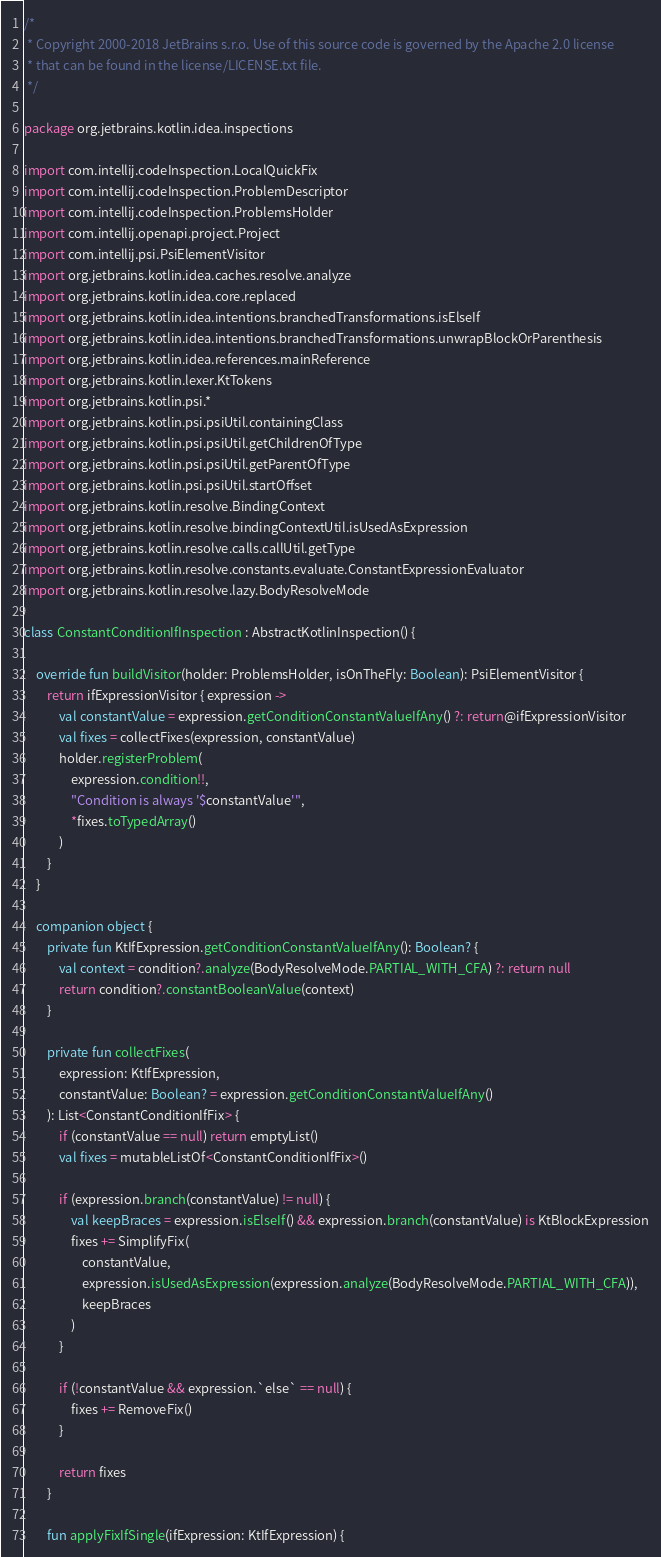<code> <loc_0><loc_0><loc_500><loc_500><_Kotlin_>/*
 * Copyright 2000-2018 JetBrains s.r.o. Use of this source code is governed by the Apache 2.0 license
 * that can be found in the license/LICENSE.txt file.
 */

package org.jetbrains.kotlin.idea.inspections

import com.intellij.codeInspection.LocalQuickFix
import com.intellij.codeInspection.ProblemDescriptor
import com.intellij.codeInspection.ProblemsHolder
import com.intellij.openapi.project.Project
import com.intellij.psi.PsiElementVisitor
import org.jetbrains.kotlin.idea.caches.resolve.analyze
import org.jetbrains.kotlin.idea.core.replaced
import org.jetbrains.kotlin.idea.intentions.branchedTransformations.isElseIf
import org.jetbrains.kotlin.idea.intentions.branchedTransformations.unwrapBlockOrParenthesis
import org.jetbrains.kotlin.idea.references.mainReference
import org.jetbrains.kotlin.lexer.KtTokens
import org.jetbrains.kotlin.psi.*
import org.jetbrains.kotlin.psi.psiUtil.containingClass
import org.jetbrains.kotlin.psi.psiUtil.getChildrenOfType
import org.jetbrains.kotlin.psi.psiUtil.getParentOfType
import org.jetbrains.kotlin.psi.psiUtil.startOffset
import org.jetbrains.kotlin.resolve.BindingContext
import org.jetbrains.kotlin.resolve.bindingContextUtil.isUsedAsExpression
import org.jetbrains.kotlin.resolve.calls.callUtil.getType
import org.jetbrains.kotlin.resolve.constants.evaluate.ConstantExpressionEvaluator
import org.jetbrains.kotlin.resolve.lazy.BodyResolveMode

class ConstantConditionIfInspection : AbstractKotlinInspection() {

    override fun buildVisitor(holder: ProblemsHolder, isOnTheFly: Boolean): PsiElementVisitor {
        return ifExpressionVisitor { expression ->
            val constantValue = expression.getConditionConstantValueIfAny() ?: return@ifExpressionVisitor
            val fixes = collectFixes(expression, constantValue)
            holder.registerProblem(
                expression.condition!!,
                "Condition is always '$constantValue'",
                *fixes.toTypedArray()
            )
        }
    }

    companion object {
        private fun KtIfExpression.getConditionConstantValueIfAny(): Boolean? {
            val context = condition?.analyze(BodyResolveMode.PARTIAL_WITH_CFA) ?: return null
            return condition?.constantBooleanValue(context)
        }

        private fun collectFixes(
            expression: KtIfExpression,
            constantValue: Boolean? = expression.getConditionConstantValueIfAny()
        ): List<ConstantConditionIfFix> {
            if (constantValue == null) return emptyList()
            val fixes = mutableListOf<ConstantConditionIfFix>()

            if (expression.branch(constantValue) != null) {
                val keepBraces = expression.isElseIf() && expression.branch(constantValue) is KtBlockExpression
                fixes += SimplifyFix(
                    constantValue,
                    expression.isUsedAsExpression(expression.analyze(BodyResolveMode.PARTIAL_WITH_CFA)),
                    keepBraces
                )
            }

            if (!constantValue && expression.`else` == null) {
                fixes += RemoveFix()
            }

            return fixes
        }

        fun applyFixIfSingle(ifExpression: KtIfExpression) {</code> 